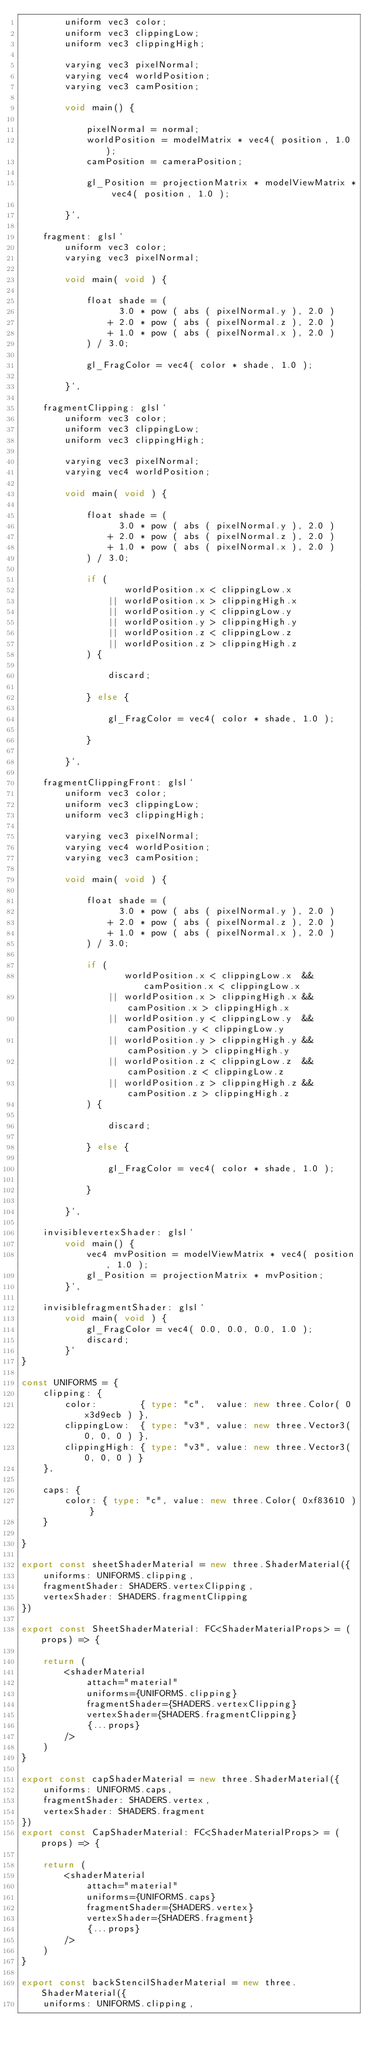Convert code to text. <code><loc_0><loc_0><loc_500><loc_500><_TypeScript_>		uniform vec3 color;
		uniform vec3 clippingLow;
		uniform vec3 clippingHigh;
		
		varying vec3 pixelNormal;
		varying vec4 worldPosition;
		varying vec3 camPosition;
		
		void main() {
			
			pixelNormal = normal;
			worldPosition = modelMatrix * vec4( position, 1.0 );
			camPosition = cameraPosition;
			
			gl_Position = projectionMatrix * modelViewMatrix * vec4( position, 1.0 );
			
		}`,

	fragment: glsl`
		uniform vec3 color;
		varying vec3 pixelNormal;
		
		void main( void ) {
			
			float shade = (
				  3.0 * pow ( abs ( pixelNormal.y ), 2.0 )
				+ 2.0 * pow ( abs ( pixelNormal.z ), 2.0 )
				+ 1.0 * pow ( abs ( pixelNormal.x ), 2.0 )
			) / 3.0;
			
			gl_FragColor = vec4( color * shade, 1.0 );
			
		}`,

	fragmentClipping: glsl`
		uniform vec3 color;
		uniform vec3 clippingLow;
		uniform vec3 clippingHigh;
		
		varying vec3 pixelNormal;
		varying vec4 worldPosition;
		
		void main( void ) {
			
			float shade = (
				  3.0 * pow ( abs ( pixelNormal.y ), 2.0 )
				+ 2.0 * pow ( abs ( pixelNormal.z ), 2.0 )
				+ 1.0 * pow ( abs ( pixelNormal.x ), 2.0 )
			) / 3.0;
			
			if (
				   worldPosition.x < clippingLow.x
				|| worldPosition.x > clippingHigh.x
				|| worldPosition.y < clippingLow.y
				|| worldPosition.y > clippingHigh.y
				|| worldPosition.z < clippingLow.z
				|| worldPosition.z > clippingHigh.z
			) {
				
				discard;
				
			} else {
				
				gl_FragColor = vec4( color * shade, 1.0 );
				
			}
			
		}`,

	fragmentClippingFront: glsl`
		uniform vec3 color;
		uniform vec3 clippingLow;
		uniform vec3 clippingHigh;
		
		varying vec3 pixelNormal;
		varying vec4 worldPosition;
		varying vec3 camPosition;
		
		void main( void ) {
			
			float shade = (
				  3.0 * pow ( abs ( pixelNormal.y ), 2.0 )
				+ 2.0 * pow ( abs ( pixelNormal.z ), 2.0 )
				+ 1.0 * pow ( abs ( pixelNormal.x ), 2.0 )
			) / 3.0;
			
			if (
				   worldPosition.x < clippingLow.x  && camPosition.x < clippingLow.x
				|| worldPosition.x > clippingHigh.x && camPosition.x > clippingHigh.x
				|| worldPosition.y < clippingLow.y  && camPosition.y < clippingLow.y
				|| worldPosition.y > clippingHigh.y && camPosition.y > clippingHigh.y
				|| worldPosition.z < clippingLow.z  && camPosition.z < clippingLow.z
				|| worldPosition.z > clippingHigh.z && camPosition.z > clippingHigh.z
			) {
				
				discard;
				
			} else {
				
				gl_FragColor = vec4( color * shade, 1.0 );
				
			}
			
		}`,

	invisiblevertexShader: glsl`
		void main() {
			vec4 mvPosition = modelViewMatrix * vec4( position, 1.0 );
			gl_Position = projectionMatrix * mvPosition;
		}`,

	invisiblefragmentShader: glsl`
		void main( void ) {
			gl_FragColor = vec4( 0.0, 0.0, 0.0, 1.0 );
			discard;
		}`
}

const UNIFORMS = {
    clipping: {
		color:        { type: "c",  value: new three.Color( 0x3d9ecb ) },
		clippingLow:  { type: "v3", value: new three.Vector3( 0, 0, 0 ) },
		clippingHigh: { type: "v3", value: new three.Vector3( 0, 0, 0 ) }
	},

	caps: {
		color: { type: "c", value: new three.Color( 0xf83610 ) }
	}

}

export const sheetShaderMaterial = new three.ShaderMaterial({
	uniforms: UNIFORMS.clipping,
	fragmentShader: SHADERS.vertexClipping,
	vertexShader: SHADERS.fragmentClipping
})

export const SheetShaderMaterial: FC<ShaderMaterialProps> = (props) => {
	
	return (
		<shaderMaterial 
			attach="material" 
			uniforms={UNIFORMS.clipping} 
			fragmentShader={SHADERS.vertexClipping} 
			vertexShader={SHADERS.fragmentClipping} 
			{...props} 
		/>
	)
}

export const capShaderMaterial = new three.ShaderMaterial({
	uniforms: UNIFORMS.caps,
	fragmentShader: SHADERS.vertex,
	vertexShader: SHADERS.fragment
})
export const CapShaderMaterial: FC<ShaderMaterialProps> = (props) => {
	
	return (
		<shaderMaterial 
			attach="material" 
			uniforms={UNIFORMS.caps} 
			fragmentShader={SHADERS.vertex} 
			vertexShader={SHADERS.fragment} 
			{...props} 
		/>
	)
}

export const backStencilShaderMaterial = new three.ShaderMaterial({
	uniforms: UNIFORMS.clipping,</code> 